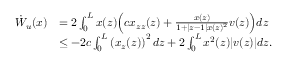<formula> <loc_0><loc_0><loc_500><loc_500>\begin{array} { r l } { \dot { W } _ { u } ( x ) } & { = 2 \int _ { 0 } ^ { L } { x ( z ) \left ( c x _ { z z } ( z ) + \frac { x ( z ) } { 1 + | z - 1 | x ( z ) ^ { 2 } } v ( z ) \right ) } d z } \\ & { \leq - 2 c \int _ { 0 } ^ { L } \left ( x _ { z } ( z ) \right ) ^ { 2 } d z + 2 \int _ { 0 } ^ { L } { x ^ { 2 } ( z ) | v ( z ) | d z } . } \end{array}</formula> 